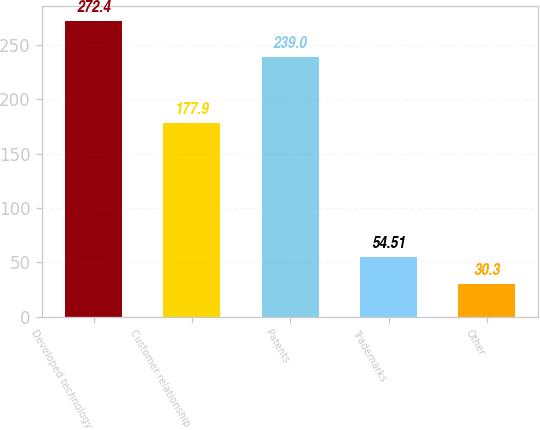Convert chart to OTSL. <chart><loc_0><loc_0><loc_500><loc_500><bar_chart><fcel>Developed technology<fcel>Customer relationship<fcel>Patents<fcel>Trademarks<fcel>Other<nl><fcel>272.4<fcel>177.9<fcel>239<fcel>54.51<fcel>30.3<nl></chart> 